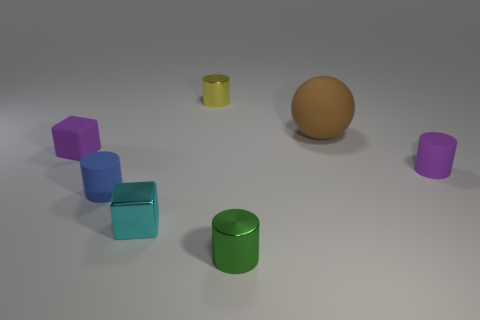What textures are visible on the objects? The objects exhibit two primary textures: matte and metallic. The three cubes and both cylinders have matte textures, which do not reflect much light, whereas the spherical object has a metallic texture, which is apparent due to its reflective surface.  Can you infer something about the lighting in this scene? The lighting in this scene seems to be diffused and coming from an overhead source, as indicated by the soft shadows projected underneath the objects. The shadows are subtle, suggesting an environment with a broad light source, or possibly a setting with ambient light supplemented by a gentler directional light. 